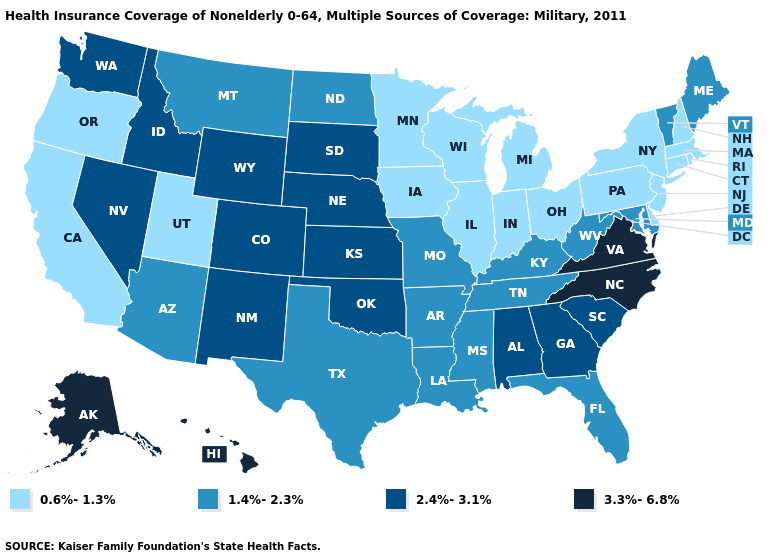What is the value of Vermont?
Concise answer only. 1.4%-2.3%. Among the states that border Georgia , does Alabama have the highest value?
Write a very short answer. No. What is the value of Kentucky?
Short answer required. 1.4%-2.3%. Does Maryland have a higher value than Missouri?
Write a very short answer. No. Name the states that have a value in the range 3.3%-6.8%?
Answer briefly. Alaska, Hawaii, North Carolina, Virginia. What is the lowest value in the USA?
Keep it brief. 0.6%-1.3%. Among the states that border Arkansas , does Oklahoma have the highest value?
Write a very short answer. Yes. Does the first symbol in the legend represent the smallest category?
Be succinct. Yes. Among the states that border New York , which have the highest value?
Concise answer only. Vermont. What is the value of Minnesota?
Write a very short answer. 0.6%-1.3%. What is the lowest value in the USA?
Write a very short answer. 0.6%-1.3%. What is the value of South Carolina?
Quick response, please. 2.4%-3.1%. Does Nebraska have the highest value in the MidWest?
Keep it brief. Yes. What is the highest value in the USA?
Be succinct. 3.3%-6.8%. What is the value of Kentucky?
Write a very short answer. 1.4%-2.3%. 